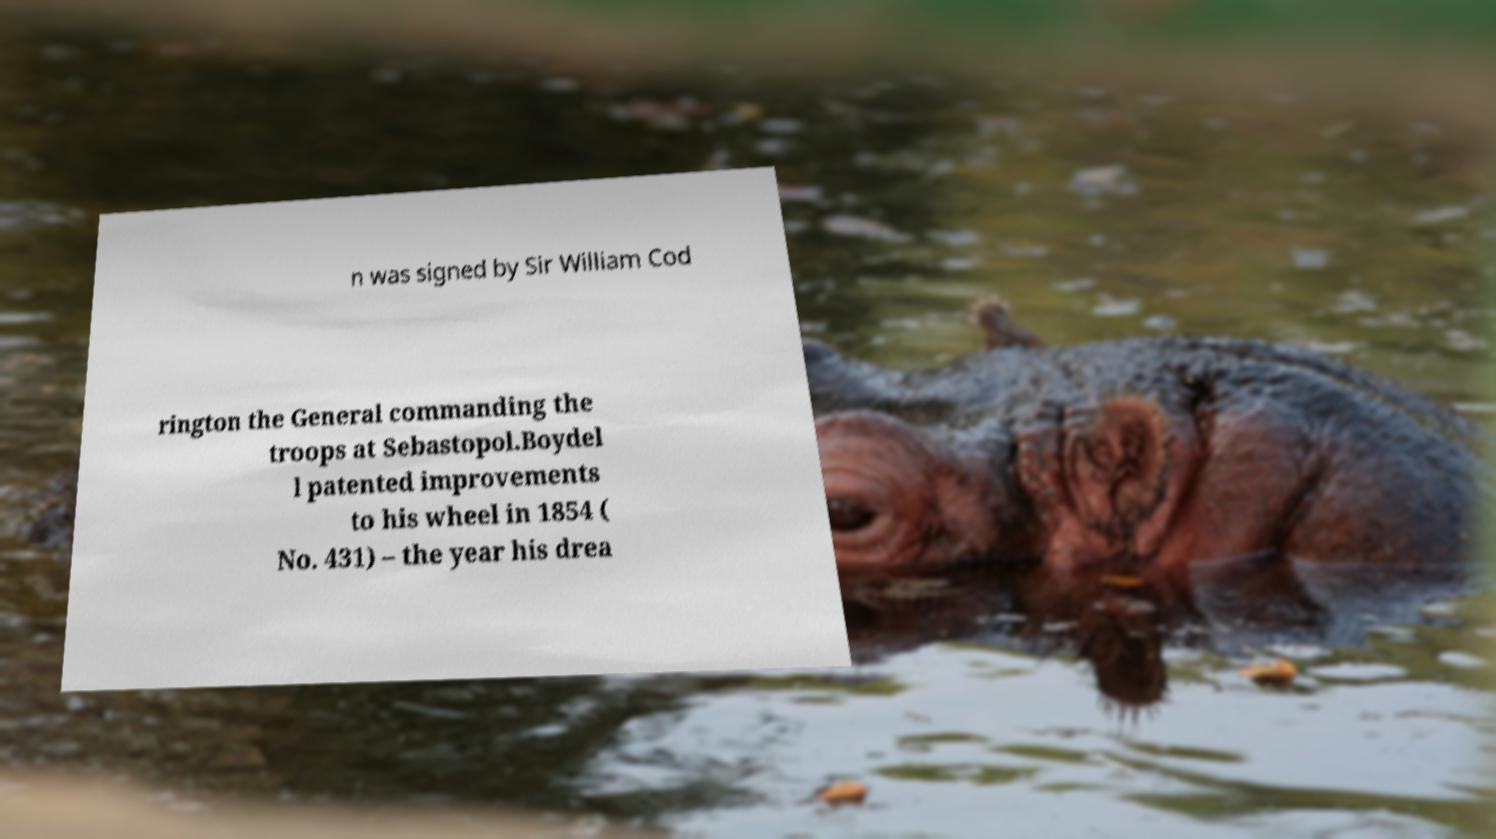Could you assist in decoding the text presented in this image and type it out clearly? n was signed by Sir William Cod rington the General commanding the troops at Sebastopol.Boydel l patented improvements to his wheel in 1854 ( No. 431) – the year his drea 